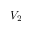<formula> <loc_0><loc_0><loc_500><loc_500>V _ { 2 }</formula> 